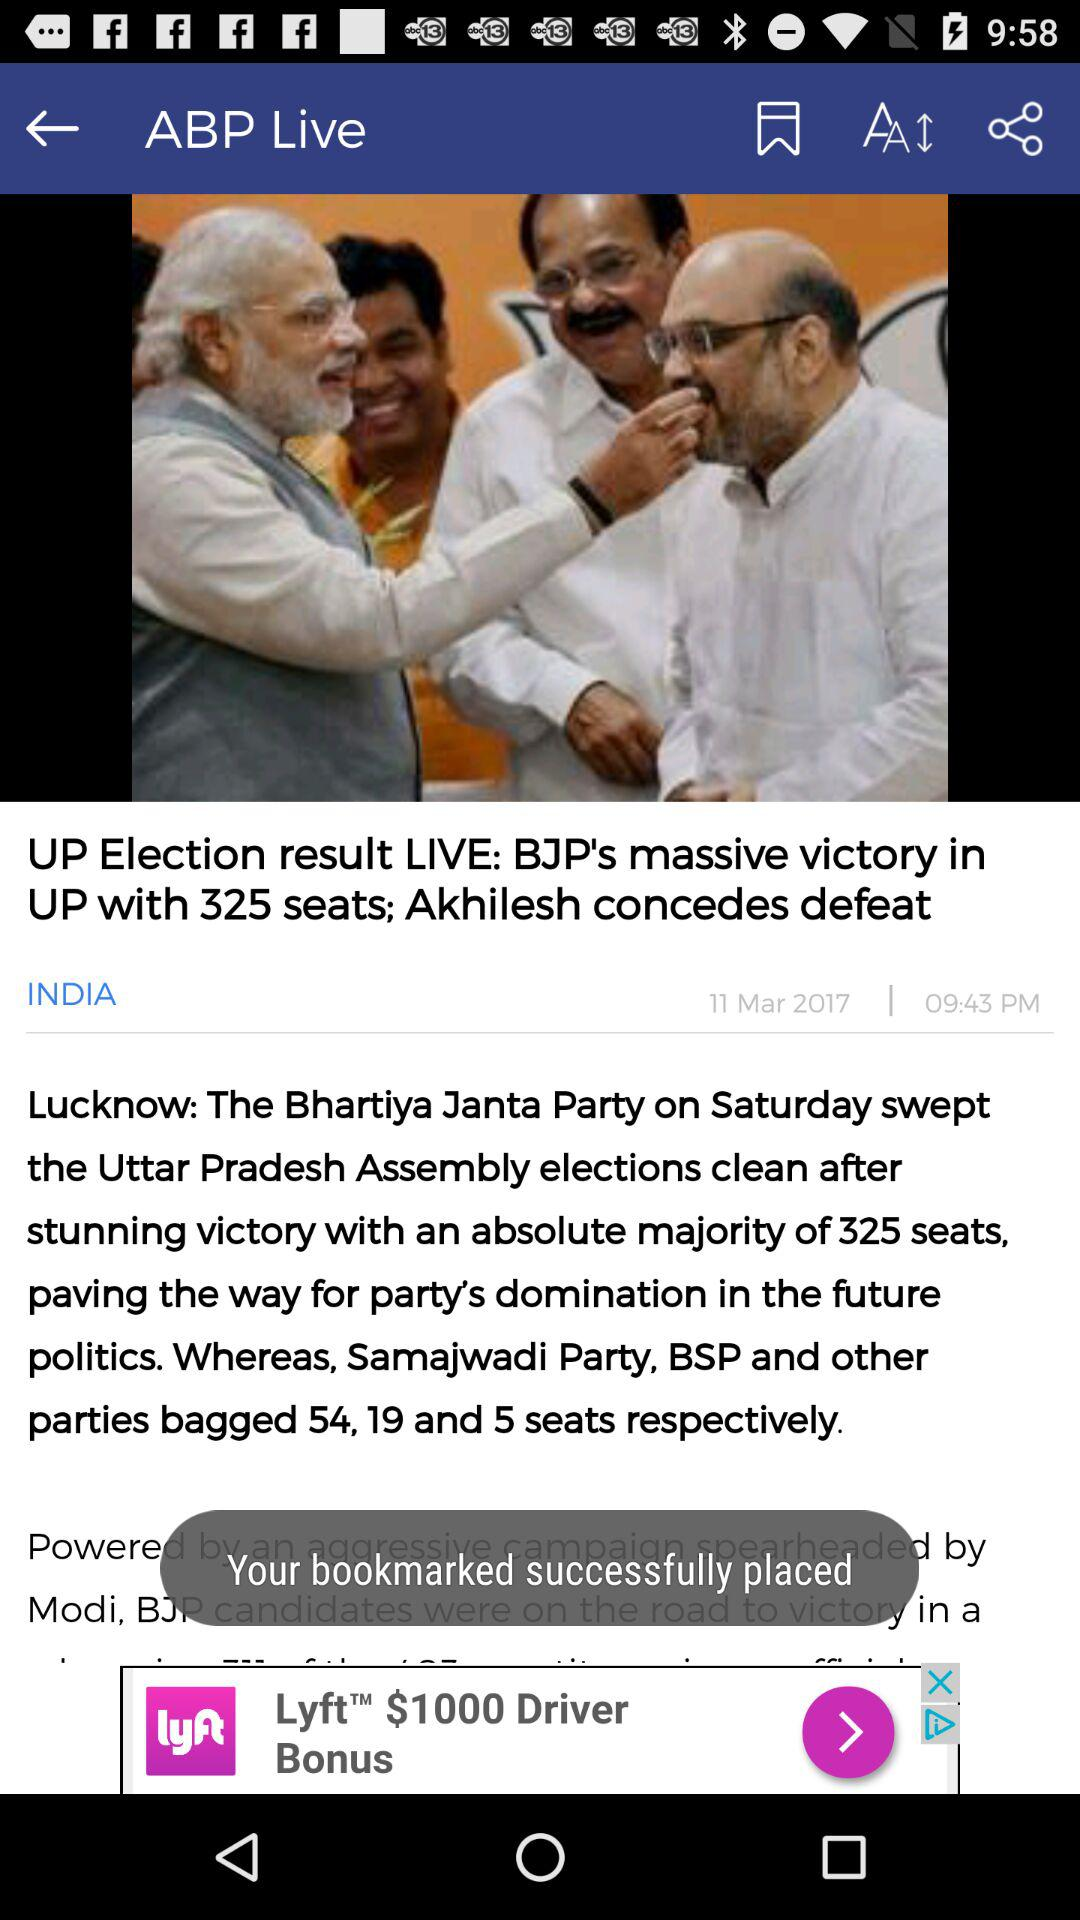What is the news headline given on the screen? The news headline given on the screen is "UP Election result LIVE: BJP's massive victory in UP with 325 seats; Akhilesh concedes defeat". 